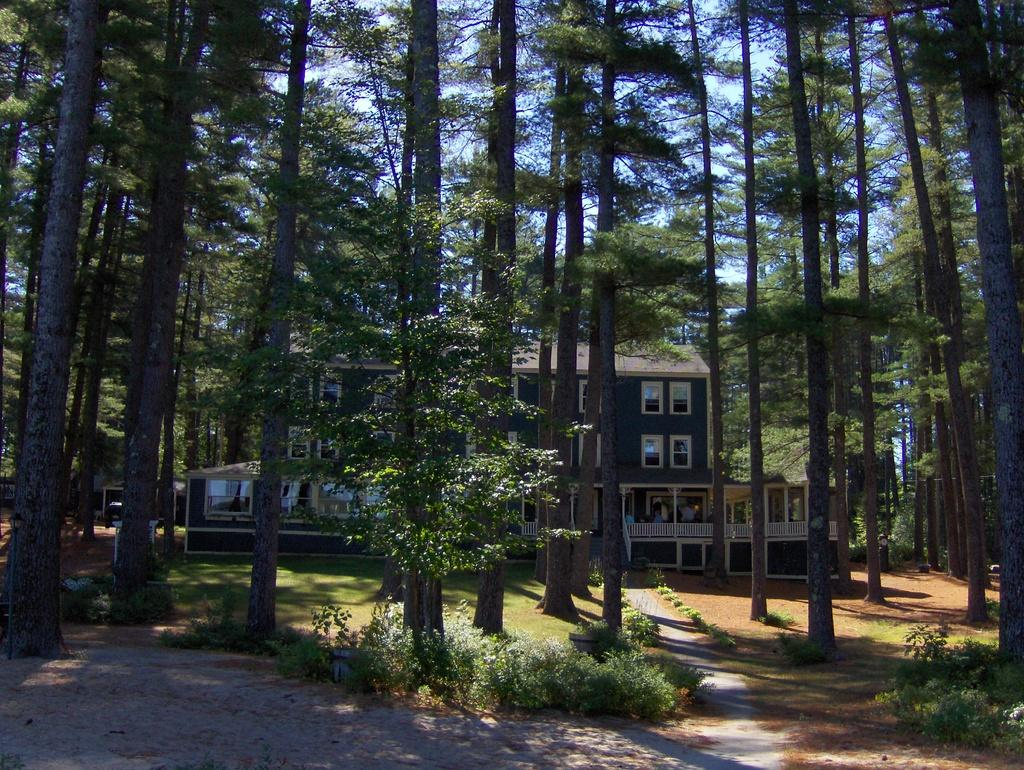What type of structure is present in the image? There is a building in the image. What type of vegetation can be seen in the image? There are trees, grass, and plants in the image. What are the poles used for in the image? The purpose of the poles is not specified in the image, but they could be used for various purposes such as signage or lighting. What part of the building can be seen in the image? The windows of the building are visible in the image. Who or what is present in the image? There are people in the image. What is visible in the background of the image? The sky is visible in the background of the image. Can you tell me how many bones are visible in the image? There are no bones present in the image. What type of friction is being generated by the tent in the image? There is no tent present in the image, so friction cannot be generated by a tent. 